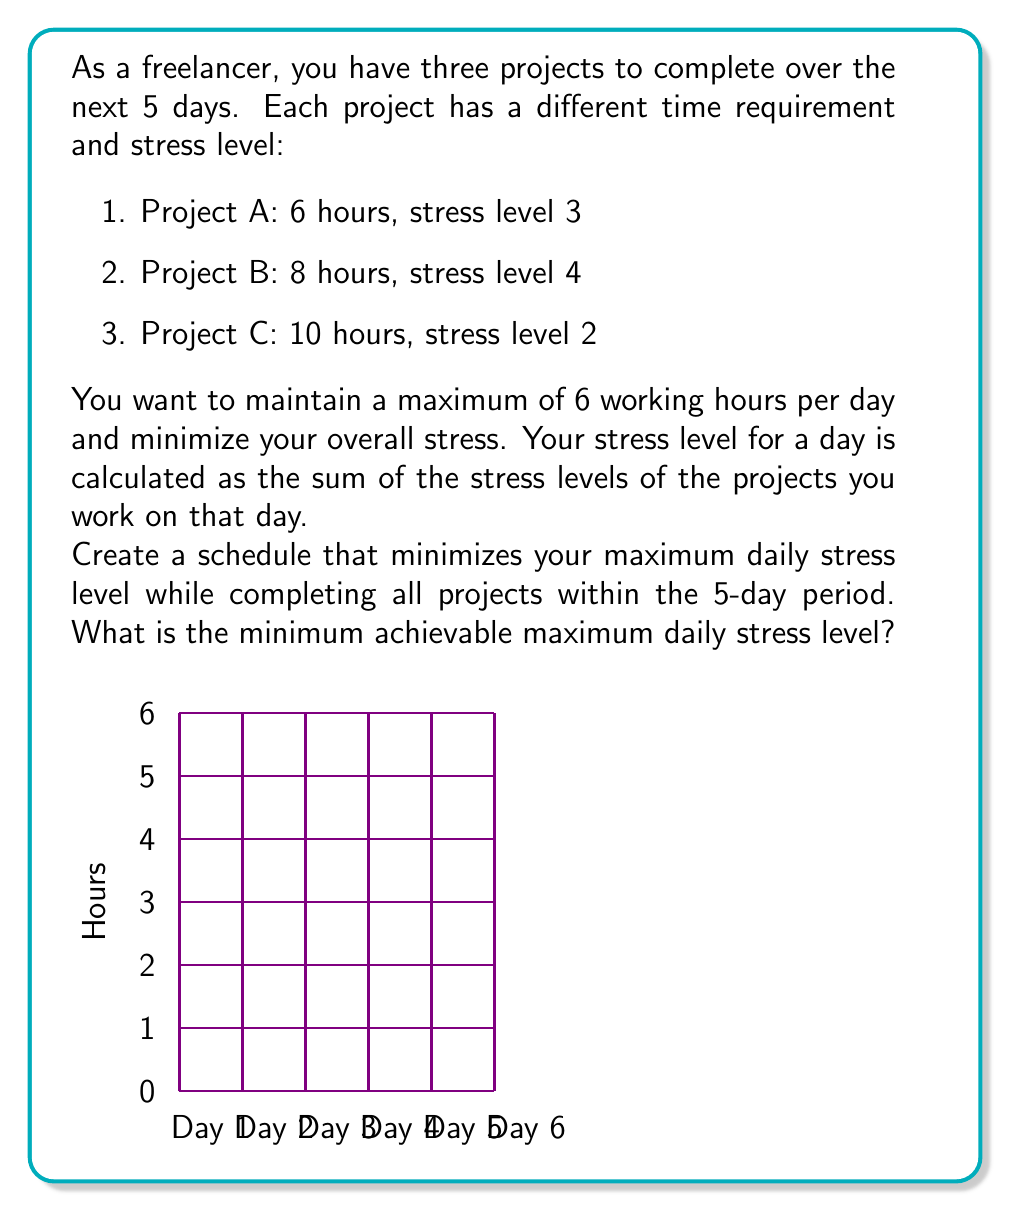Give your solution to this math problem. Let's approach this problem step-by-step:

1) First, we need to calculate the total working hours:
   $6 + 8 + 10 = 24$ hours

2) With a maximum of 6 hours per day over 5 days, we have $6 \times 5 = 30$ available hours, which is sufficient to complete all projects.

3) To minimize the maximum daily stress, we should try to spread out the high-stress projects and combine them with low-stress projects when possible.

4) Let's start with a possible schedule:

   Day 1: Project A (6 hours, stress 3)
   Day 2: Project B (6 hours, stress 4)
   Day 3: Project B (2 hours, stress 4) + Project C (4 hours, stress 2)
   Day 4: Project C (6 hours, stress 2)
   Day 5: No work (or buffer time)

5) In this schedule, the maximum daily stress is 4 (on Days 2 and 3).

6) Can we improve this? Let's try to split Project B across three days instead of two:

   Day 1: Project A (6 hours, stress 3)
   Day 2: Project B (4 hours, stress 4) + Project C (2 hours, stress 2)
   Day 3: Project B (4 hours, stress 4) + Project C (2 hours, stress 2)
   Day 4: Project C (6 hours, stress 2)
   Day 5: No work (or buffer time)

7) In this improved schedule, the maximum daily stress is 3 + 2 = 5 (on Days 2 and 3).

8) This is the optimal solution because:
   - We can't split Project A (6 hours) across days without exceeding the 6-hour daily limit.
   - Splitting Project B more would increase the number of high-stress days.
   - Project C is already optimally distributed to balance stress.

Therefore, the minimum achievable maximum daily stress level is 5.
Answer: 5 